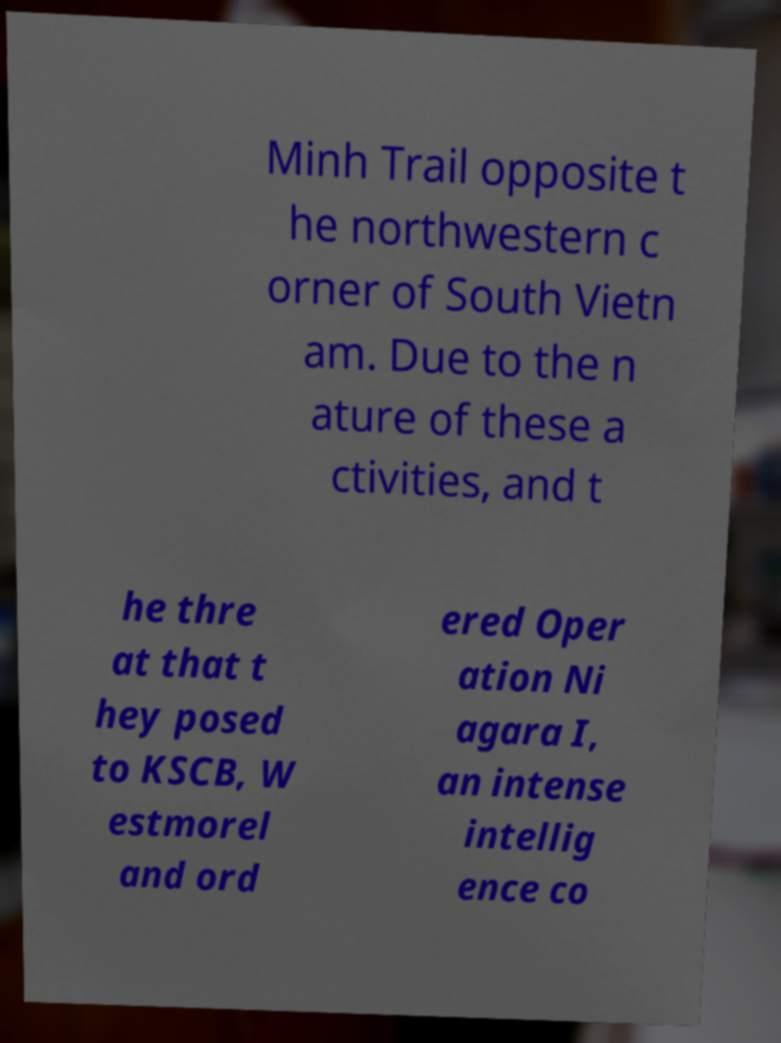Please read and relay the text visible in this image. What does it say? Minh Trail opposite t he northwestern c orner of South Vietn am. Due to the n ature of these a ctivities, and t he thre at that t hey posed to KSCB, W estmorel and ord ered Oper ation Ni agara I, an intense intellig ence co 